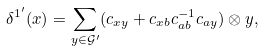<formula> <loc_0><loc_0><loc_500><loc_500>\delta ^ { 1 ^ { \prime } } ( x ) = \sum _ { y \in \mathcal { G } ^ { \prime } } ( c _ { x y } + c _ { x b } c _ { a b } ^ { - 1 } c _ { a y } ) \otimes y ,</formula> 